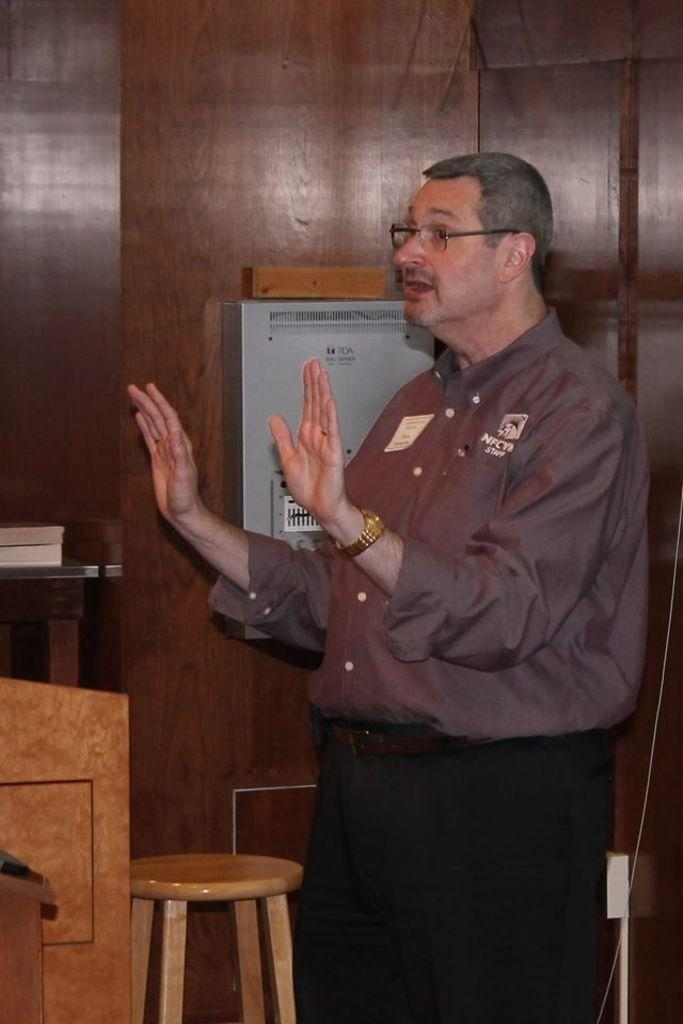What is the man in the image doing? The man is standing in the image and explaining something. What objects can be seen in the background of the image? There is a chair, a table, a book, and a box in the background of the image. What type of bells can be heard ringing in the image? There are no bells present in the image, and therefore no sound can be heard. 